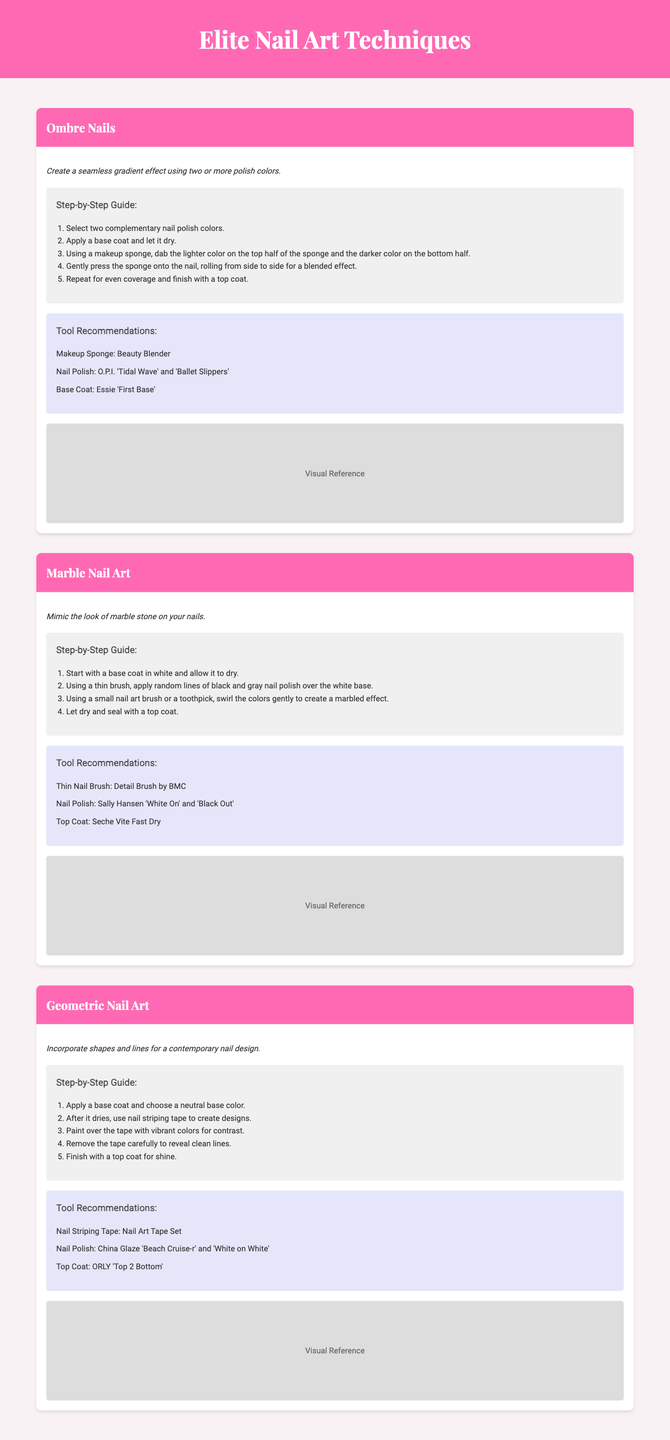What is the title of the catalog? The title of the catalog is mentioned in the header section of the document.
Answer: Elite Nail Art Techniques What nail polish colors are recommended for Ombre Nails? The document lists specific nail polish colors for the Ombre Nails technique.
Answer: O.P.I. 'Tidal Wave' and 'Ballet Slippers' How many steps are involved in creating Marble Nail Art? The number of steps can be counted from the Marble Nail Art section.
Answer: 4 What is the main purpose of the Geometric Nail Art technique? The document provides a brief description of the goal of the Geometric Nail Art technique.
Answer: Incorporate shapes and lines for a contemporary nail design Which type of tool is recommended for applying the Ombre Nails technique? The tool recommendation section for Ombre Nails specifies a tool type.
Answer: Makeup Sponge What is the first step in the Marble Nail Art process? The first step is clearly outlined in the steps for Marble Nail Art.
Answer: Start with a base coat in white and allow it to dry What color is suggested as a neutral base for Geometric Nail Art? The document states the base color required for creating Geometric Nail Art.
Answer: Neutral base color What is the recommended top coat for Marble Nail Art? The tool recommendations for Marble Nail Art include a specific top coat.
Answer: Seche Vite Fast Dry 